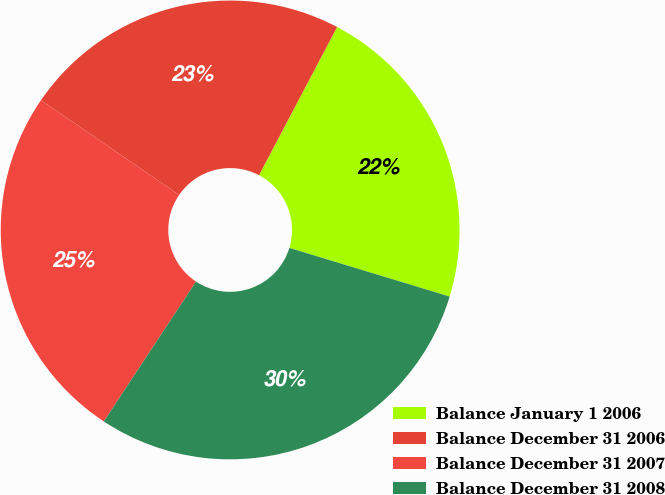<chart> <loc_0><loc_0><loc_500><loc_500><pie_chart><fcel>Balance January 1 2006<fcel>Balance December 31 2006<fcel>Balance December 31 2007<fcel>Balance December 31 2008<nl><fcel>21.97%<fcel>23.15%<fcel>25.29%<fcel>29.59%<nl></chart> 